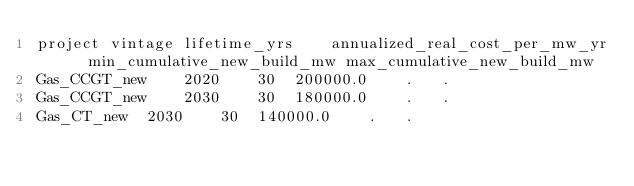Convert code to text. <code><loc_0><loc_0><loc_500><loc_500><_SQL_>project	vintage	lifetime_yrs	annualized_real_cost_per_mw_yr	min_cumulative_new_build_mw	max_cumulative_new_build_mw
Gas_CCGT_new	2020	30	200000.0	.	.
Gas_CCGT_new	2030	30	180000.0	.	.
Gas_CT_new	2030	30	140000.0	.	.
</code> 